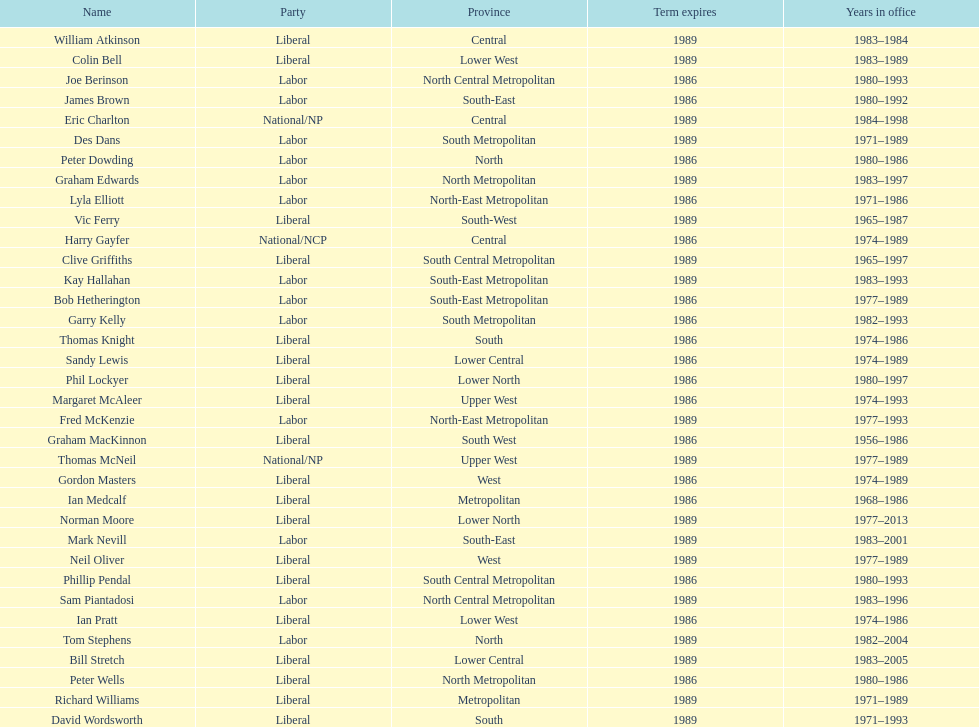What was phil lockyer's party? Liberal. 